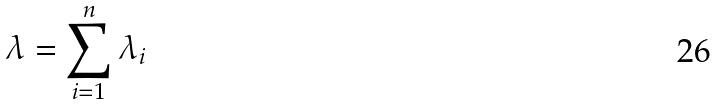Convert formula to latex. <formula><loc_0><loc_0><loc_500><loc_500>\lambda = \sum _ { i = 1 } ^ { n } \lambda _ { i }</formula> 